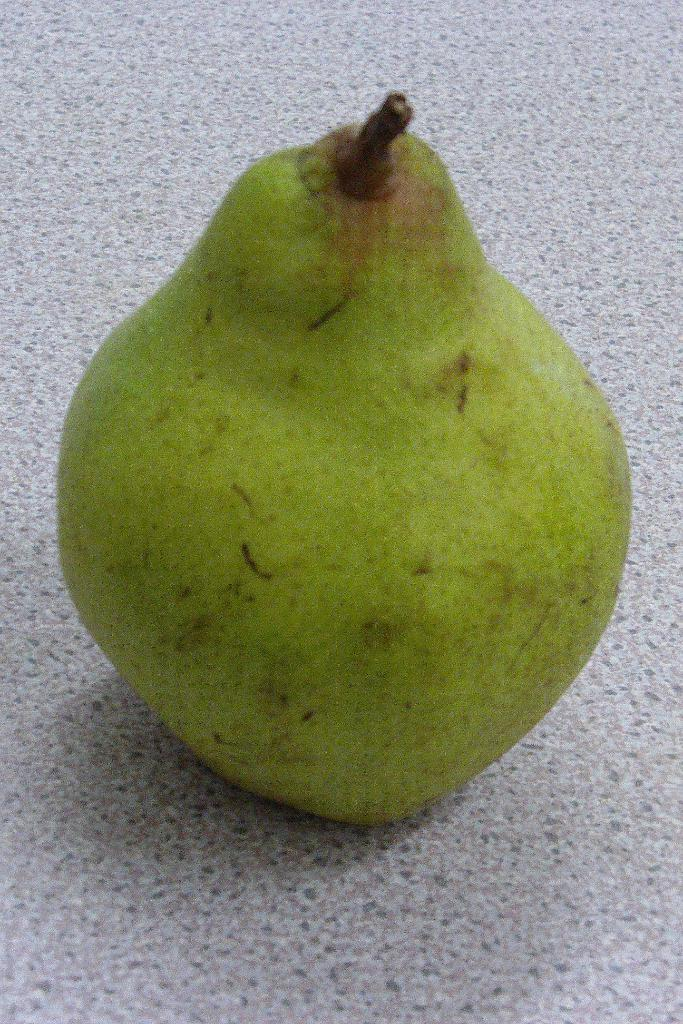What type of fruit is present in the image? There is green color fruit in the image. Where is the fruit located? The fruit is placed on the floor. What is the color of the floor? The floor is in grey color. Can you see any mice running around the fruit in the image? There are no mice present in the image. What type of wind, zephyr, can be felt in the image? The image does not depict any wind or weather conditions, so it is not possible to determine if a zephyr can be felt. 